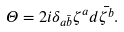<formula> <loc_0><loc_0><loc_500><loc_500>\Theta = 2 i \delta _ { a \bar { b } } \zeta ^ { a } d \bar { \zeta ^ { b } } .</formula> 